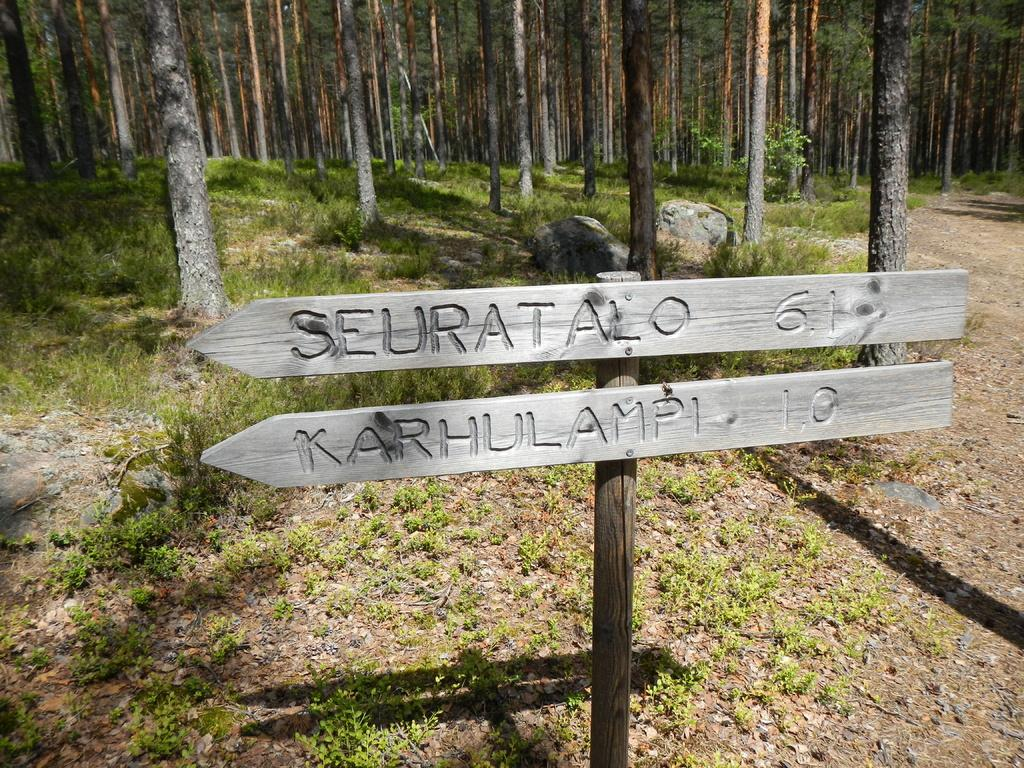What can be seen on the name boards in the image? The specific content of the name boards cannot be determined from the image. What type of natural environment is visible in the background of the image? There are trees and rocks in the background of the image. What type of surface is visible in the image? There is ground visible in the image. How many parts of regret can be seen in the image? There is no mention of regret or any related concept in the image, so it cannot be determined how many parts of regret might be present. 